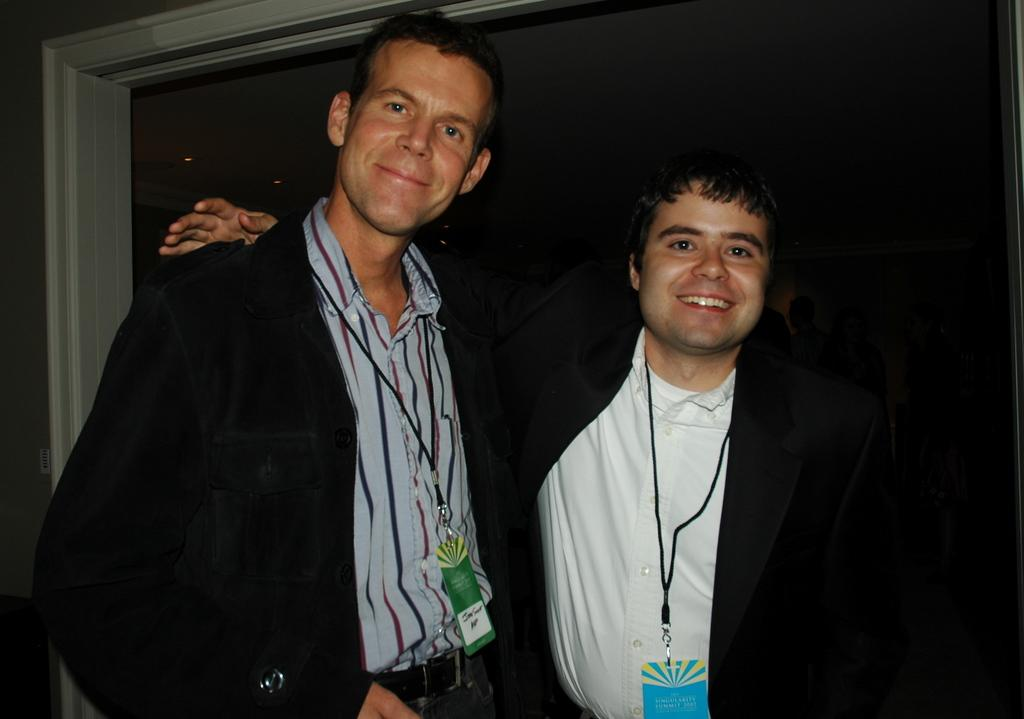How many people are in the image? There are two men in the image. What are the men doing in the image? The men are standing and smiling. What are the men wearing in the image? The men are wearing blazers. What can be seen in the backdrop of the image? There is a window and a wall in the backdrop of the image. What type of doll is sitting on the neck of one of the men in the image? There is no doll present in the image, and no mention of a neck or any object sitting on it. 